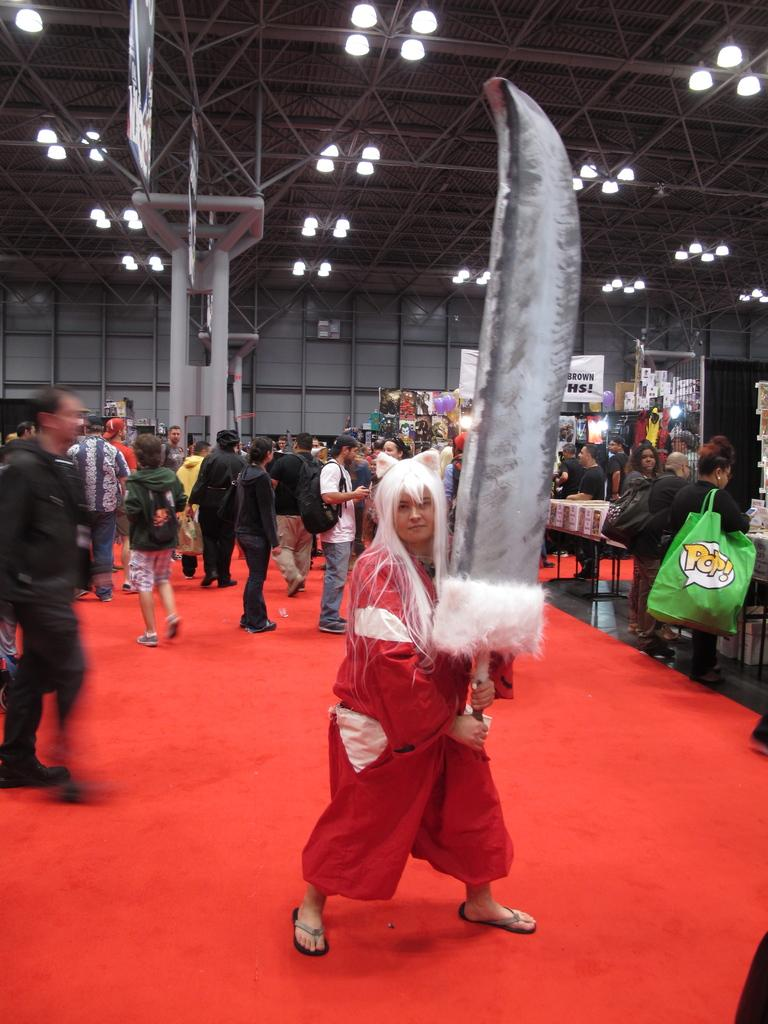What type of flooring is visible in the image? There is a red color carpet in the image. What type of furniture can be seen in the image? There are chairs in the image. Are there any people present in the image? Yes, there are people in the image. What structural elements are visible in the image? There are iron rods in the image. What other objects can be seen in the image? There is a big knife in the image. What type of scarecrow is standing near the church in the image? There is no scarecrow or church present in the image. How many wheels can be seen on the vehicles in the image? There are no vehicles or wheels present in the image. 